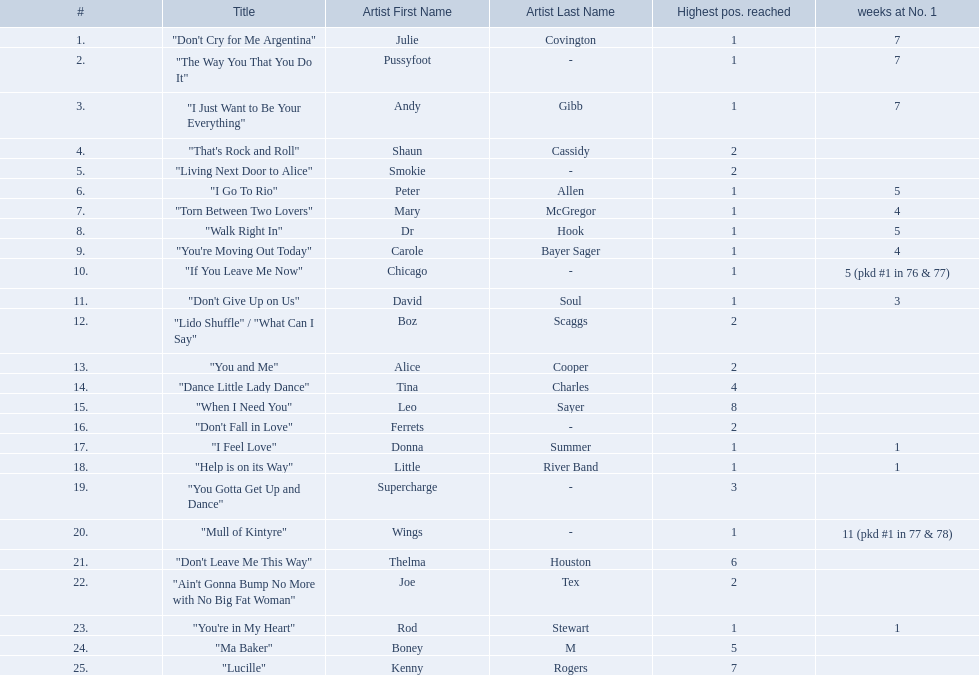Which artists were included in the top 25 singles for 1977 in australia? Julie Covington, Pussyfoot, Andy Gibb, Shaun Cassidy, Smokie, Peter Allen, Mary McGregor, Dr Hook, Carole Bayer Sager, Chicago, David Soul, Boz Scaggs, Alice Cooper, Tina Charles, Leo Sayer, Ferrets, Donna Summer, Little River Band, Supercharge, Wings, Thelma Houston, Joe Tex, Rod Stewart, Boney M, Kenny Rogers. And for how many weeks did they chart at number 1? 7, 7, 7, , , 5, 4, 5, 4, 5 (pkd #1 in 76 & 77), 3, , , , , , 1, 1, , 11 (pkd #1 in 77 & 78), , , 1, , . Which artist was in the number 1 spot for most time? Wings. 